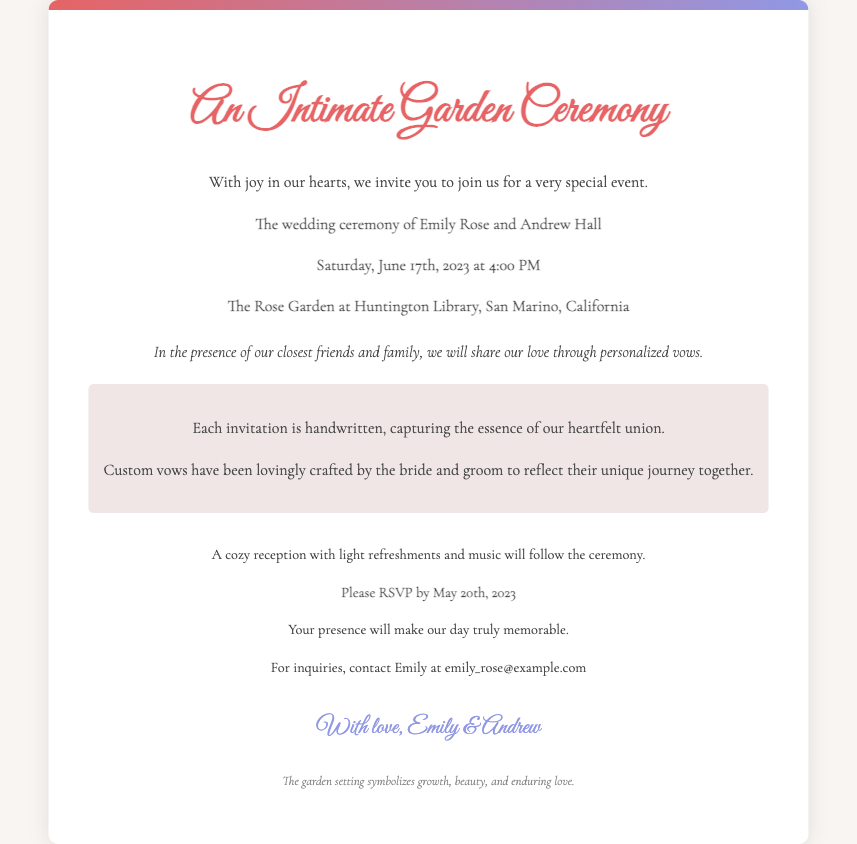What are the names of the couple? The names mentioned in the document for the couple are Emily Rose and Andrew Hall.
Answer: Emily Rose and Andrew Hall What is the date of the wedding? The wedding is scheduled for Saturday, June 17th, 2023.
Answer: June 17th, 2023 Where is the ceremony taking place? The location specified for the ceremony is The Rose Garden at Huntington Library, San Marino, California.
Answer: The Rose Garden at Huntington Library, San Marino, California What time does the ceremony start? The ceremony is set to start at 4:00 PM on the specified date.
Answer: 4:00 PM What special aspect of the vows is highlighted? The document mentions that the vows are personalized and custom-crafted by the couple.
Answer: Personalized vows Why is the invitation handwritten? The handwritten invitations are meant to capture the essence of their heartfelt union.
Answer: To capture the essence of their heartfelt union By when should guests RSVP? Guests are asked to RSVP by May 20th, 2023, as mentioned in the document.
Answer: May 20th, 2023 What follows the wedding ceremony? The document notes that a cozy reception with light refreshments and music will follow.
Answer: A cozy reception What does the garden setting symbolize? The footnote in the invitation states that the garden setting symbolizes growth, beauty, and enduring love.
Answer: Growth, beauty, and enduring love 